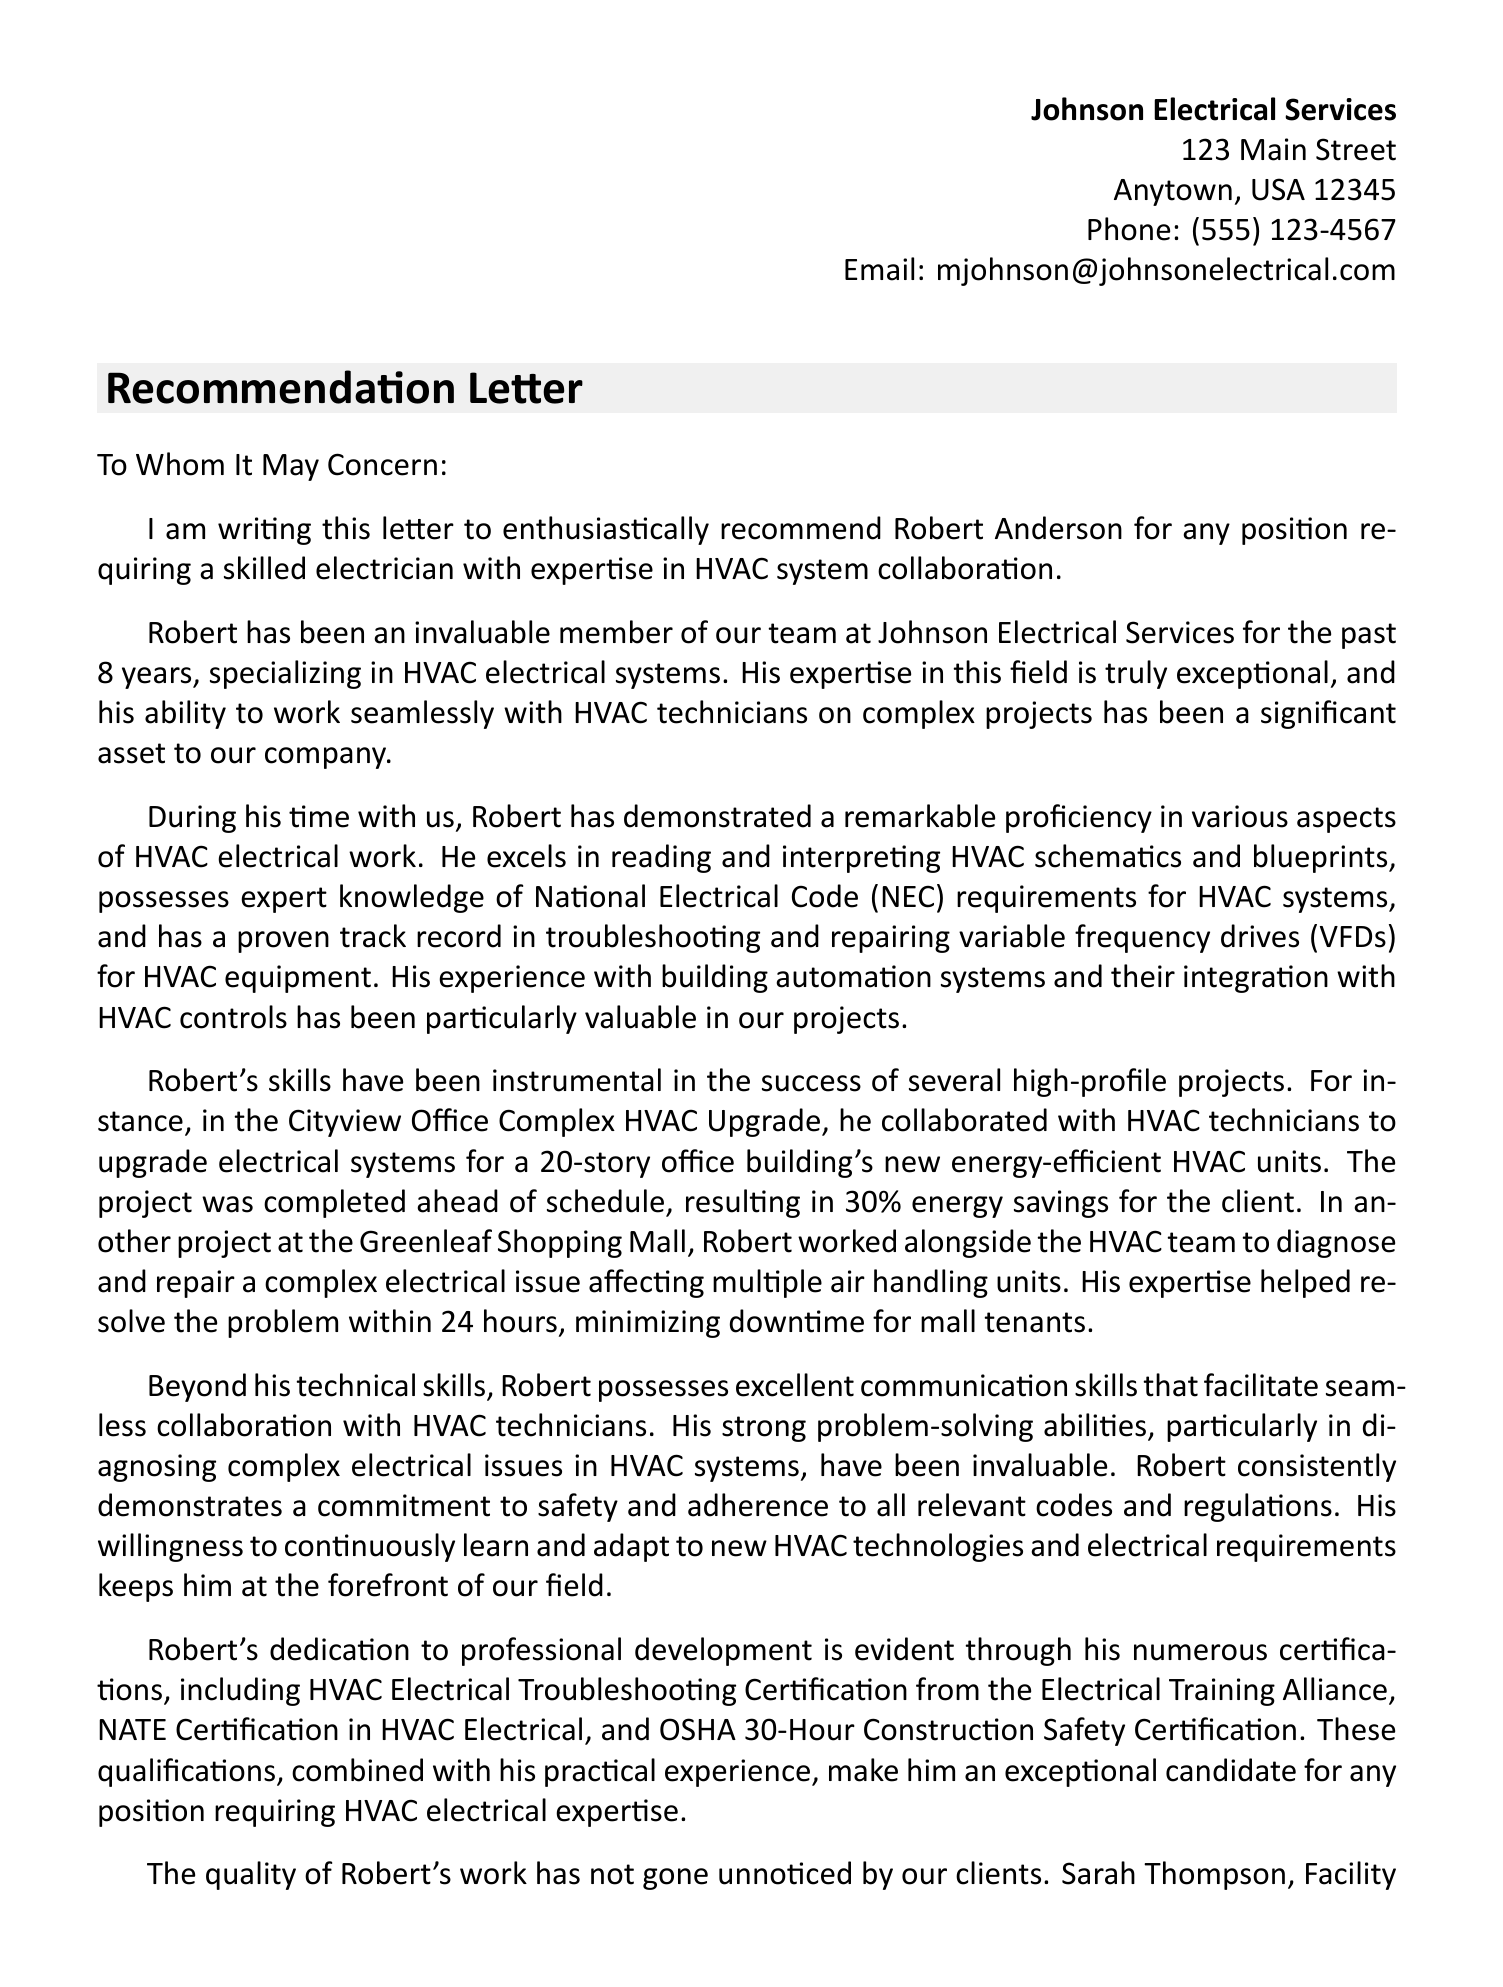What is the name of the electrician being recommended? The letter explicitly mentions "Robert Anderson" as the electrician being recommended.
Answer: Robert Anderson How many years of experience does the electrician have? The letter states that Robert has been with Johnson Electrical Services for 8 years.
Answer: 8 What is the specialization of the electrician? The document highlights that Robert specializes in HVAC electrical systems.
Answer: HVAC electrical systems Who is the author of the recommendation letter? The letter is signed by Michael Johnson, who is identified as the owner of Johnson Electrical Services.
Answer: Michael Johnson What was the outcome of the Cityview Office Complex HVAC Upgrade? The letter states the project resulted in 30% energy savings for the client.
Answer: 30% energy savings Which certification is mentioned that relates to HVAC electrical troubleshooting? The letter mentions the HVAC Electrical Troubleshooting Certification from the Electrical Training Alliance.
Answer: HVAC Electrical Troubleshooting Certification What quality of Robert is highlighted in relation to his collaboration with HVAC technicians? The letter emphasizes his excellent communication skills that facilitate seamless collaboration with HVAC technicians.
Answer: Excellent communication skills How quickly did Robert resolve the electrical issue at the Greenleaf Shopping Mall? The letter indicates that Robert resolved the problem within 24 hours.
Answer: 24 hours What is one of the personal qualities highlighted about Robert? The letter mentions his strong problem-solving abilities, particularly in diagnosing complex electrical issues in HVAC systems.
Answer: Strong problem-solving abilities 